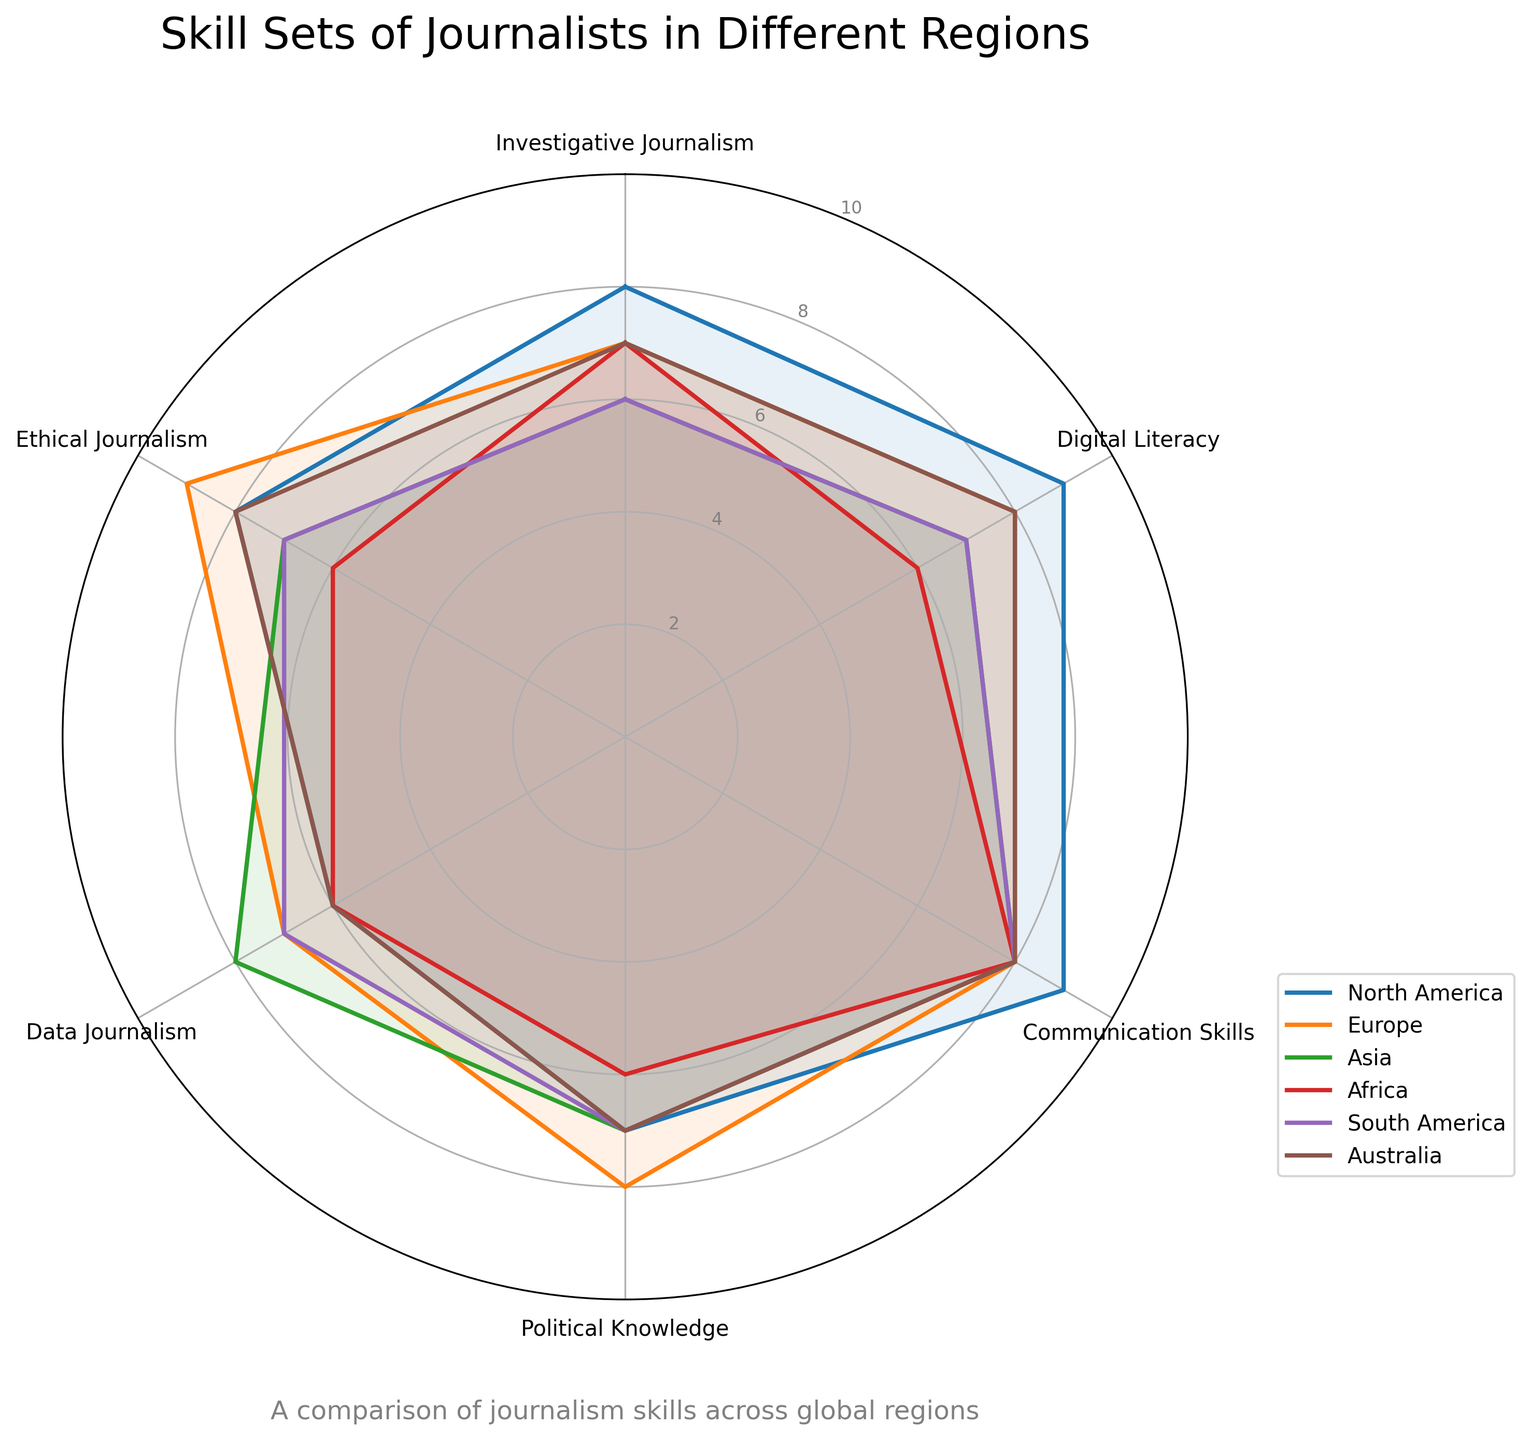What's the title of the radar chart? The title is prominently displayed at the top of the chart. The title provides an overview of what the figure represents. By looking at the top of the chart, we find "Skill Sets of Journalists in Different Regions."
Answer: Skill Sets of Journalists in Different Regions What are the six skills included in the radar chart? The skills are indicated at each axis of the radar chart. By reading the labels on the outer edge of the chart at each point, we see the skills listed as Investigative Journalism, Digital Literacy, Communication Skills, Political Knowledge, Data Journalism, Ethical Journalism.
Answer: Investigative Journalism, Digital Literacy, Communication Skills, Political Knowledge, Data Journalism, Ethical Journalism Which region has the highest score in Ethical Journalism? By examining the Ethical Journalism axis on the radar chart, we can compare the scores for each region. The region with the highest value at this axis is Europe, with a score of 9.
Answer: Europe Which region scores the lowest in Digital Literacy? To determine this, we examine the values along the Digital Literacy axis for each region. Africa has the lowest value with a score of 6.
Answer: Africa What is the average score of Investigative Journalism across all regions? We add up the values for Investigative Journalism from each region: 8 (North America) + 7 (Europe) + 6 (Asia) + 7 (Africa) + 6 (South America) + 7 (Australia) = 41. Then we divide by the number of regions (6): 41 / 6 ≈ 6.83.
Answer: 6.83 How does Asia's score in Data Journalism compare to North America's? We compare the positions of Asia and North America along the Data Journalism axis. Asia scores 8, while North America scores 6, so Asia has a higher score.
Answer: Asia has a higher score What are the top three skills for journalists in South America based on their scores? We look at the values provided for South America and rank them. The scores are Communication Skills (8), Data Journalism (7), and Digital Literacy (7). The top three skills are therefore Communication Skills, Data Journalism, and Digital Literacy.
Answer: Communication Skills, Data Journalism, Digital Literacy Which two regions have the most similar skill set profiles overall? By visually comparing the shapes of the plots for each region, we look for regions with similar radial patterns. Europe and Australia have the most similar profiles as all their scores are either identical or close.
Answer: Europe and Australia Which skill shows the most variation in scores across different regions? To determine this, we compare the highest and lowest scores for each skill. Investigative Journalism varies from 6 to 8, Digital Literacy varies from 6 to 9, Communication Skills is consistent at 8, Political Knowledge varies from 6 to 8, Data Journalism varies from 6 to 8, Ethical Journalism varies from 6 to 9. Digital Literacy and Ethical Journalism both have the highest range of 3 points.
Answer: Digital Literacy, Ethical Journalism What is the difference in Political Knowledge scores between Europe and Africa? We examine the Political Knowledge scores for Europe and Africa. Europe scores 8, while Africa scores 6. The difference is 8 - 6 = 2.
Answer: 2 